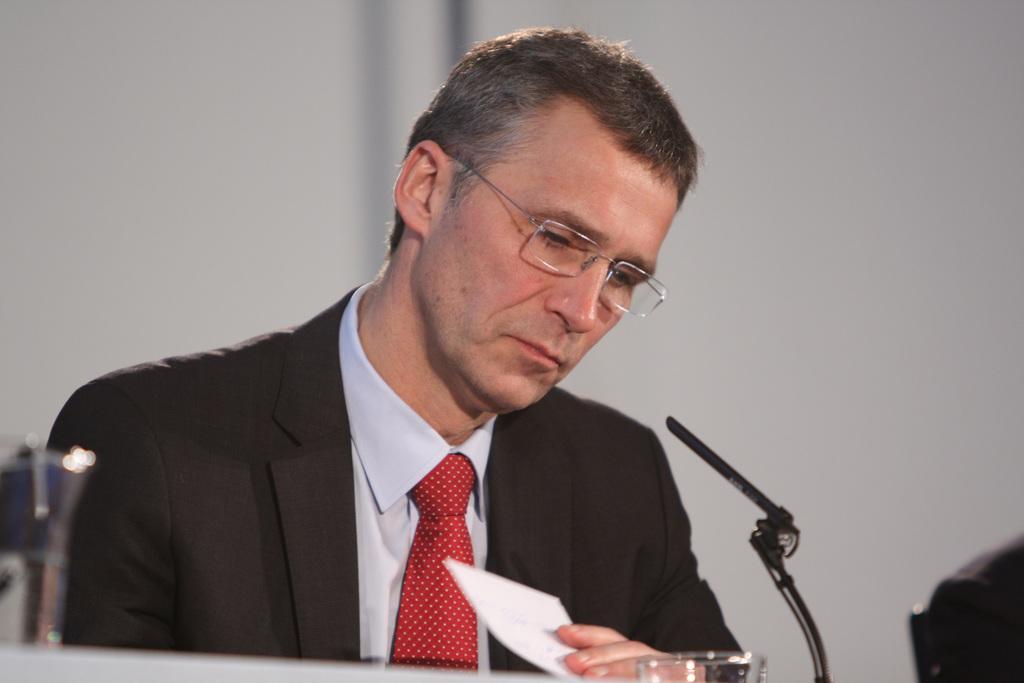Describe this image in one or two sentences. In this image I can see the person with black blazer, white shirt and red color tie. There is a mic, paper and glass in-front of the person. In the background I can see the white wall. 